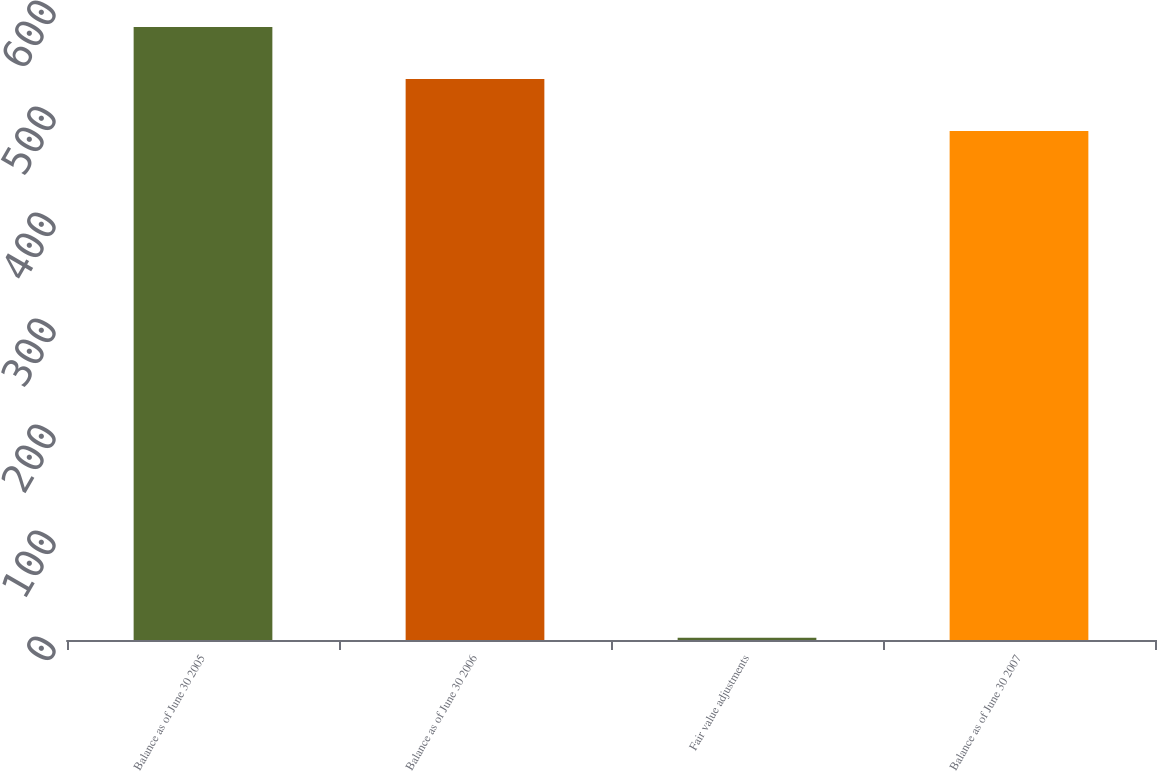Convert chart to OTSL. <chart><loc_0><loc_0><loc_500><loc_500><bar_chart><fcel>Balance as of June 30 2005<fcel>Balance as of June 30 2006<fcel>Fair value adjustments<fcel>Balance as of June 30 2007<nl><fcel>578.2<fcel>529.2<fcel>2.1<fcel>480.2<nl></chart> 